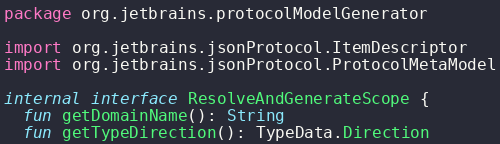<code> <loc_0><loc_0><loc_500><loc_500><_Kotlin_>package org.jetbrains.protocolModelGenerator

import org.jetbrains.jsonProtocol.ItemDescriptor
import org.jetbrains.jsonProtocol.ProtocolMetaModel

internal interface ResolveAndGenerateScope {
  fun getDomainName(): String
  fun getTypeDirection(): TypeData.Direction
</code> 